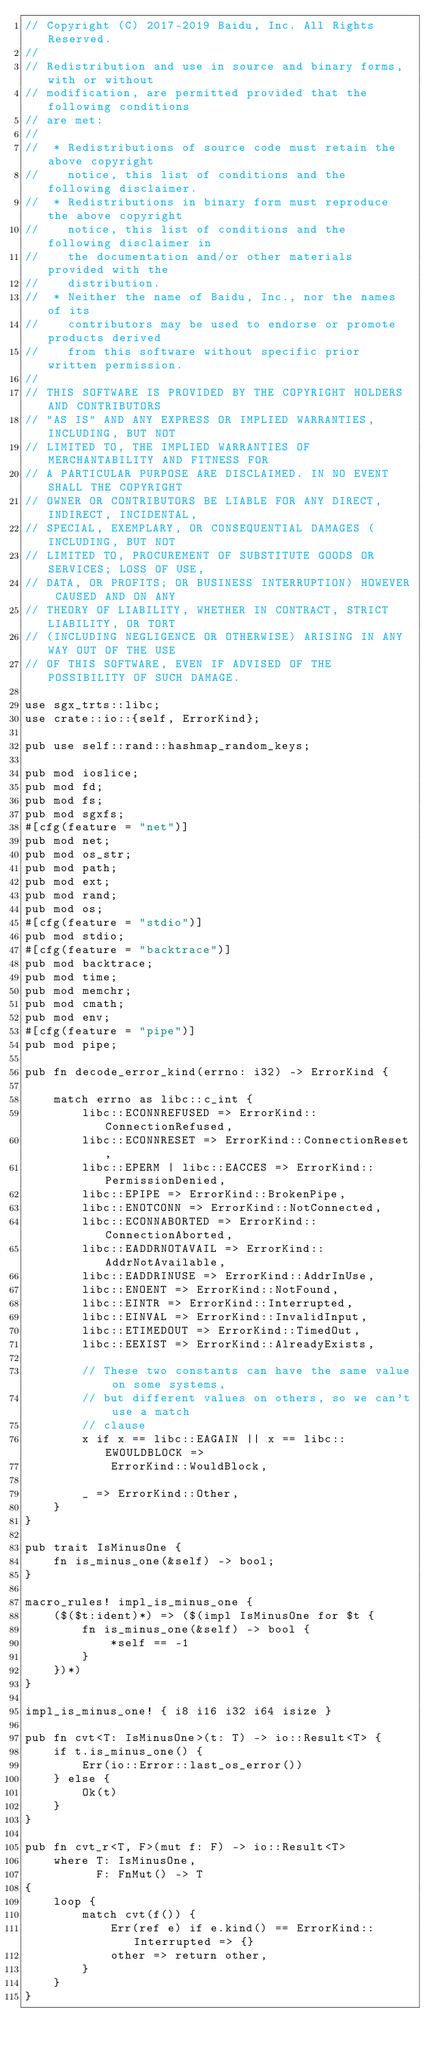<code> <loc_0><loc_0><loc_500><loc_500><_Rust_>// Copyright (C) 2017-2019 Baidu, Inc. All Rights Reserved.
//
// Redistribution and use in source and binary forms, with or without
// modification, are permitted provided that the following conditions
// are met:
//
//  * Redistributions of source code must retain the above copyright
//    notice, this list of conditions and the following disclaimer.
//  * Redistributions in binary form must reproduce the above copyright
//    notice, this list of conditions and the following disclaimer in
//    the documentation and/or other materials provided with the
//    distribution.
//  * Neither the name of Baidu, Inc., nor the names of its
//    contributors may be used to endorse or promote products derived
//    from this software without specific prior written permission.
//
// THIS SOFTWARE IS PROVIDED BY THE COPYRIGHT HOLDERS AND CONTRIBUTORS
// "AS IS" AND ANY EXPRESS OR IMPLIED WARRANTIES, INCLUDING, BUT NOT
// LIMITED TO, THE IMPLIED WARRANTIES OF MERCHANTABILITY AND FITNESS FOR
// A PARTICULAR PURPOSE ARE DISCLAIMED. IN NO EVENT SHALL THE COPYRIGHT
// OWNER OR CONTRIBUTORS BE LIABLE FOR ANY DIRECT, INDIRECT, INCIDENTAL,
// SPECIAL, EXEMPLARY, OR CONSEQUENTIAL DAMAGES (INCLUDING, BUT NOT
// LIMITED TO, PROCUREMENT OF SUBSTITUTE GOODS OR SERVICES; LOSS OF USE,
// DATA, OR PROFITS; OR BUSINESS INTERRUPTION) HOWEVER CAUSED AND ON ANY
// THEORY OF LIABILITY, WHETHER IN CONTRACT, STRICT LIABILITY, OR TORT
// (INCLUDING NEGLIGENCE OR OTHERWISE) ARISING IN ANY WAY OUT OF THE USE
// OF THIS SOFTWARE, EVEN IF ADVISED OF THE POSSIBILITY OF SUCH DAMAGE.

use sgx_trts::libc;
use crate::io::{self, ErrorKind};

pub use self::rand::hashmap_random_keys;

pub mod ioslice;
pub mod fd;
pub mod fs;
pub mod sgxfs;
#[cfg(feature = "net")]
pub mod net;
pub mod os_str;
pub mod path;
pub mod ext;
pub mod rand;
pub mod os;
#[cfg(feature = "stdio")]
pub mod stdio;
#[cfg(feature = "backtrace")]
pub mod backtrace;
pub mod time;
pub mod memchr;
pub mod cmath;
pub mod env;
#[cfg(feature = "pipe")]
pub mod pipe;

pub fn decode_error_kind(errno: i32) -> ErrorKind {

    match errno as libc::c_int {
        libc::ECONNREFUSED => ErrorKind::ConnectionRefused,
        libc::ECONNRESET => ErrorKind::ConnectionReset,
        libc::EPERM | libc::EACCES => ErrorKind::PermissionDenied,
        libc::EPIPE => ErrorKind::BrokenPipe,
        libc::ENOTCONN => ErrorKind::NotConnected,
        libc::ECONNABORTED => ErrorKind::ConnectionAborted,
        libc::EADDRNOTAVAIL => ErrorKind::AddrNotAvailable,
        libc::EADDRINUSE => ErrorKind::AddrInUse,
        libc::ENOENT => ErrorKind::NotFound,
        libc::EINTR => ErrorKind::Interrupted,
        libc::EINVAL => ErrorKind::InvalidInput,
        libc::ETIMEDOUT => ErrorKind::TimedOut,
        libc::EEXIST => ErrorKind::AlreadyExists,

        // These two constants can have the same value on some systems,
        // but different values on others, so we can't use a match
        // clause
        x if x == libc::EAGAIN || x == libc::EWOULDBLOCK =>
            ErrorKind::WouldBlock,

        _ => ErrorKind::Other,
    }
}

pub trait IsMinusOne {
    fn is_minus_one(&self) -> bool;
}

macro_rules! impl_is_minus_one {
    ($($t:ident)*) => ($(impl IsMinusOne for $t {
        fn is_minus_one(&self) -> bool {
            *self == -1
        }
    })*)
}

impl_is_minus_one! { i8 i16 i32 i64 isize }

pub fn cvt<T: IsMinusOne>(t: T) -> io::Result<T> {
    if t.is_minus_one() {
        Err(io::Error::last_os_error())
    } else {
        Ok(t)
    }
}

pub fn cvt_r<T, F>(mut f: F) -> io::Result<T>
    where T: IsMinusOne,
          F: FnMut() -> T
{
    loop {
        match cvt(f()) {
            Err(ref e) if e.kind() == ErrorKind::Interrupted => {}
            other => return other,
        }
    }
}
</code> 